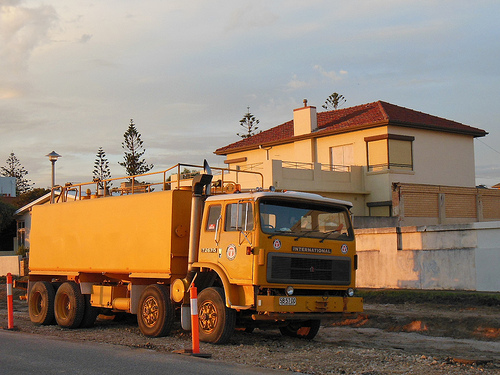Please provide a description for the region specified [0.11, 0.69, 0.17, 0.78]. This part of the image showcases another wheel of the truck, with details like tread patterns visible, indicating significant use. 